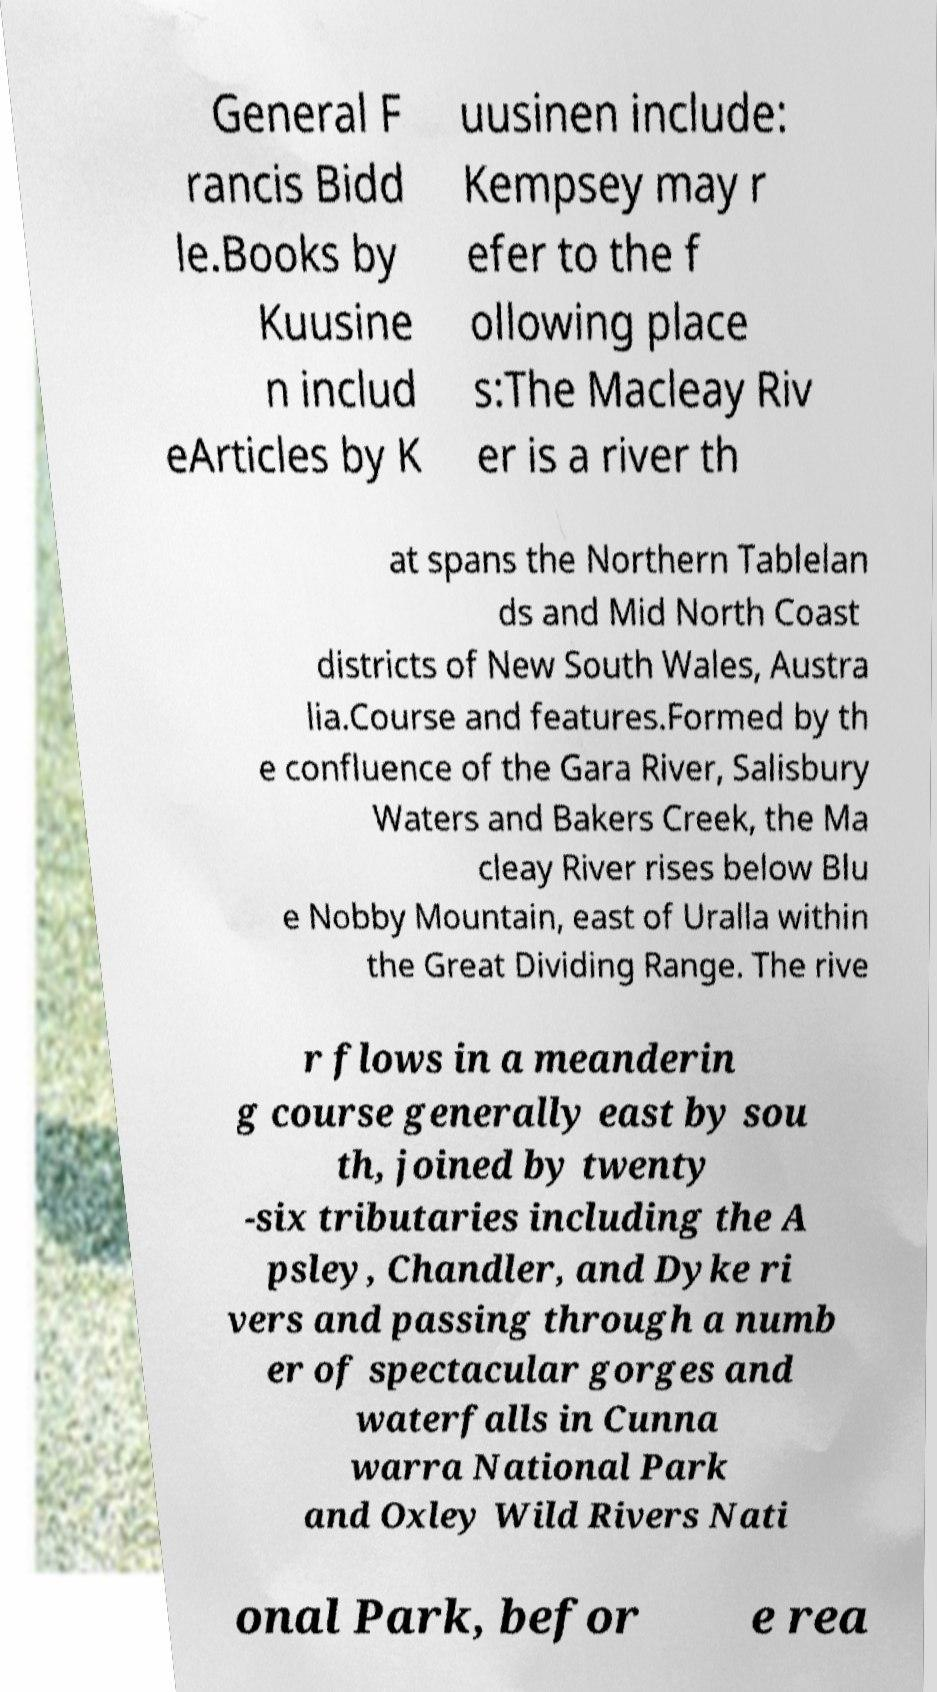I need the written content from this picture converted into text. Can you do that? General F rancis Bidd le.Books by Kuusine n includ eArticles by K uusinen include: Kempsey may r efer to the f ollowing place s:The Macleay Riv er is a river th at spans the Northern Tablelan ds and Mid North Coast districts of New South Wales, Austra lia.Course and features.Formed by th e confluence of the Gara River, Salisbury Waters and Bakers Creek, the Ma cleay River rises below Blu e Nobby Mountain, east of Uralla within the Great Dividing Range. The rive r flows in a meanderin g course generally east by sou th, joined by twenty -six tributaries including the A psley, Chandler, and Dyke ri vers and passing through a numb er of spectacular gorges and waterfalls in Cunna warra National Park and Oxley Wild Rivers Nati onal Park, befor e rea 